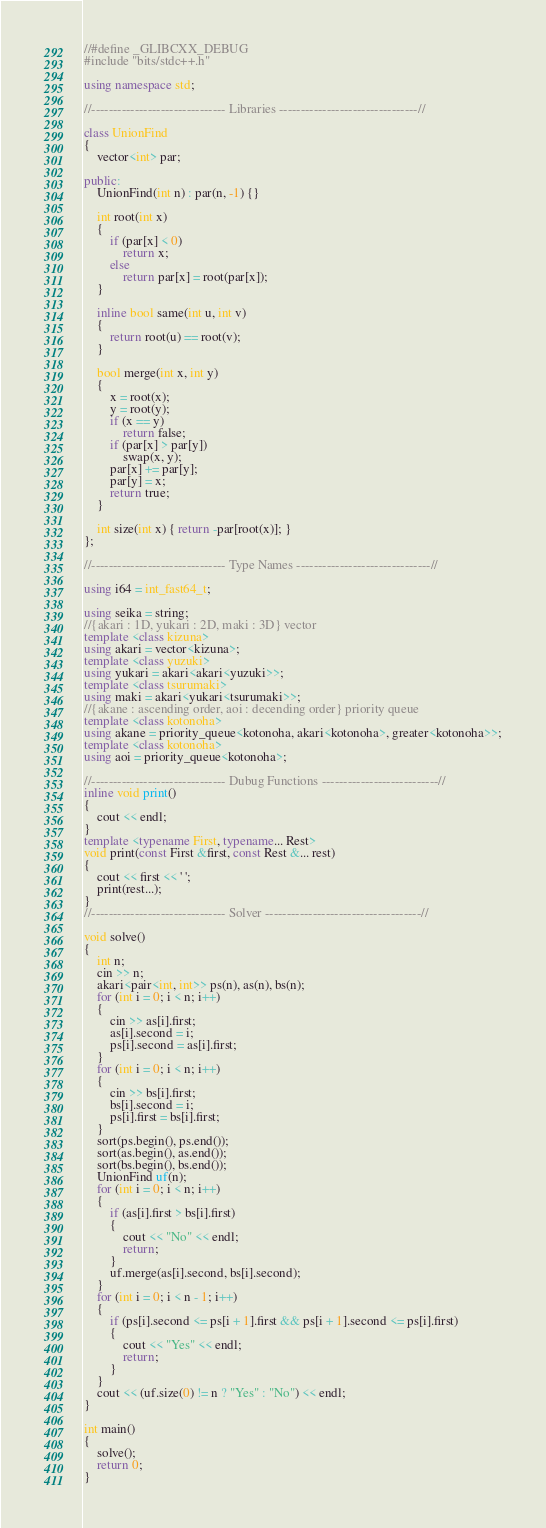<code> <loc_0><loc_0><loc_500><loc_500><_C++_>//#define _GLIBCXX_DEBUG
#include "bits/stdc++.h"

using namespace std;

//------------------------------- Libraries --------------------------------//

class UnionFind
{
    vector<int> par;

public:
    UnionFind(int n) : par(n, -1) {}

    int root(int x)
    {
        if (par[x] < 0)
            return x;
        else
            return par[x] = root(par[x]);
    }

    inline bool same(int u, int v)
    {
        return root(u) == root(v);
    }

    bool merge(int x, int y)
    {
        x = root(x);
        y = root(y);
        if (x == y)
            return false;
        if (par[x] > par[y])
            swap(x, y);
        par[x] += par[y];
        par[y] = x;
        return true;
    }

    int size(int x) { return -par[root(x)]; }
};

//------------------------------- Type Names -------------------------------//

using i64 = int_fast64_t;

using seika = string;
//{akari : 1D, yukari : 2D, maki : 3D} vector
template <class kizuna>
using akari = vector<kizuna>;
template <class yuzuki>
using yukari = akari<akari<yuzuki>>;
template <class tsurumaki>
using maki = akari<yukari<tsurumaki>>;
//{akane : ascending order, aoi : decending order} priority queue
template <class kotonoha>
using akane = priority_queue<kotonoha, akari<kotonoha>, greater<kotonoha>>;
template <class kotonoha>
using aoi = priority_queue<kotonoha>;

//------------------------------- Dubug Functions ---------------------------//
inline void print()
{
    cout << endl;
}
template <typename First, typename... Rest>
void print(const First &first, const Rest &... rest)
{
    cout << first << ' ';
    print(rest...);
}
//------------------------------- Solver ------------------------------------//

void solve()
{
    int n;
    cin >> n;
    akari<pair<int, int>> ps(n), as(n), bs(n);
    for (int i = 0; i < n; i++)
    {
        cin >> as[i].first;
        as[i].second = i;
        ps[i].second = as[i].first;
    }
    for (int i = 0; i < n; i++)
    {
        cin >> bs[i].first;
        bs[i].second = i;
        ps[i].first = bs[i].first;
    }
    sort(ps.begin(), ps.end());
    sort(as.begin(), as.end());
    sort(bs.begin(), bs.end());
    UnionFind uf(n);
    for (int i = 0; i < n; i++)
    {
        if (as[i].first > bs[i].first)
        {
            cout << "No" << endl;
            return;
        }
        uf.merge(as[i].second, bs[i].second);
    }
    for (int i = 0; i < n - 1; i++)
    {
        if (ps[i].second <= ps[i + 1].first && ps[i + 1].second <= ps[i].first)
        {
            cout << "Yes" << endl;
            return;
        }
    }
    cout << (uf.size(0) != n ? "Yes" : "No") << endl;
}

int main()
{
    solve();
    return 0;
}
</code> 